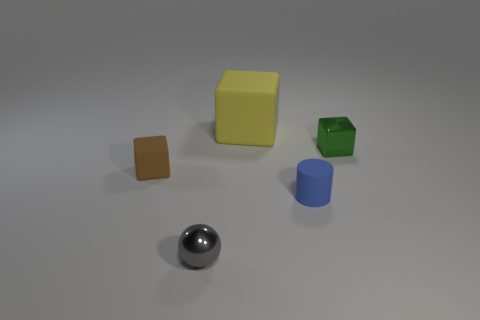Is there anything else that is the same color as the big rubber cube?
Your answer should be very brief. No. There is a small object to the left of the gray thing; what color is it?
Make the answer very short. Brown. There is a metallic object in front of the small block to the left of the blue cylinder; is there a blue thing left of it?
Offer a terse response. No. Is the number of big rubber blocks that are in front of the brown rubber cube greater than the number of large yellow cubes?
Your answer should be very brief. No. Do the small shiny thing right of the small gray ball and the tiny gray metal thing have the same shape?
Your answer should be compact. No. Are there any other things that have the same material as the ball?
Offer a terse response. Yes. How many things are brown shiny blocks or small cubes that are on the right side of the rubber cylinder?
Your response must be concise. 1. How big is the object that is both in front of the small matte cube and behind the small gray thing?
Your answer should be compact. Small. Is the number of things that are right of the small green metallic object greater than the number of balls in front of the sphere?
Keep it short and to the point. No. There is a tiny gray object; is its shape the same as the small matte thing right of the big yellow thing?
Give a very brief answer. No. 